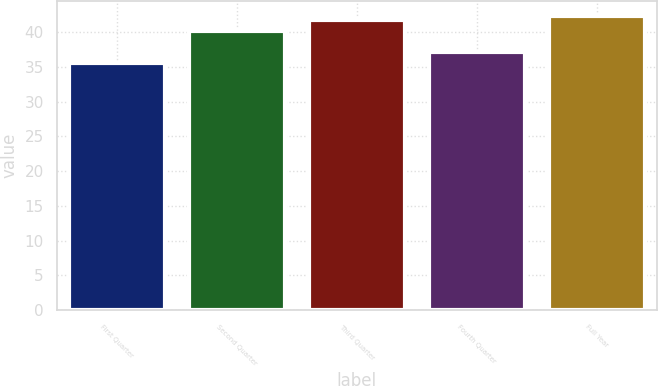Convert chart to OTSL. <chart><loc_0><loc_0><loc_500><loc_500><bar_chart><fcel>First Quarter<fcel>Second Quarter<fcel>Third Quarter<fcel>Fourth Quarter<fcel>Full Year<nl><fcel>35.52<fcel>40.16<fcel>41.69<fcel>37.13<fcel>42.31<nl></chart> 